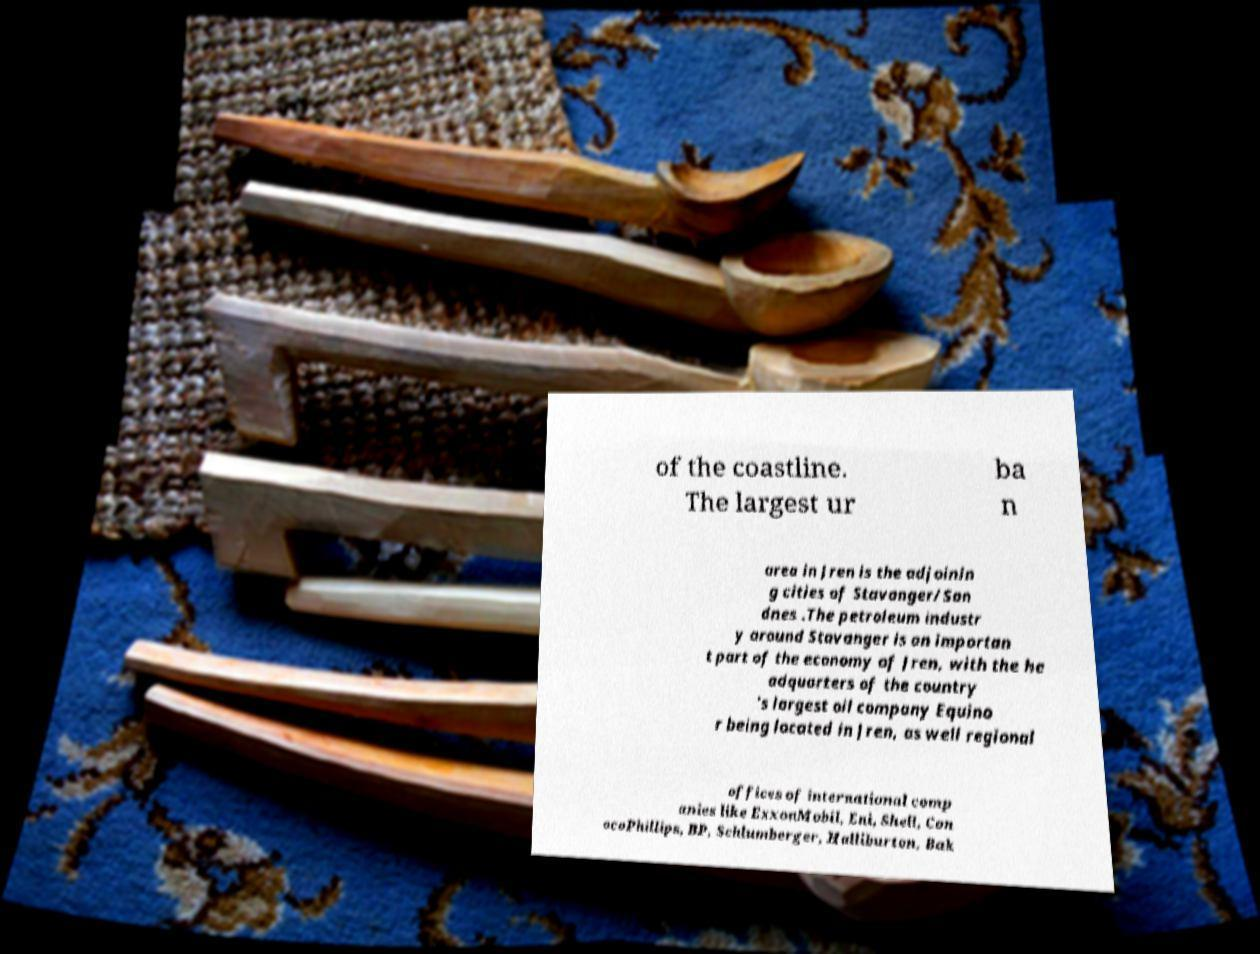Could you assist in decoding the text presented in this image and type it out clearly? of the coastline. The largest ur ba n area in Jren is the adjoinin g cities of Stavanger/San dnes .The petroleum industr y around Stavanger is an importan t part of the economy of Jren, with the he adquarters of the country 's largest oil company Equino r being located in Jren, as well regional offices of international comp anies like ExxonMobil, Eni, Shell, Con ocoPhillips, BP, Schlumberger, Halliburton, Bak 